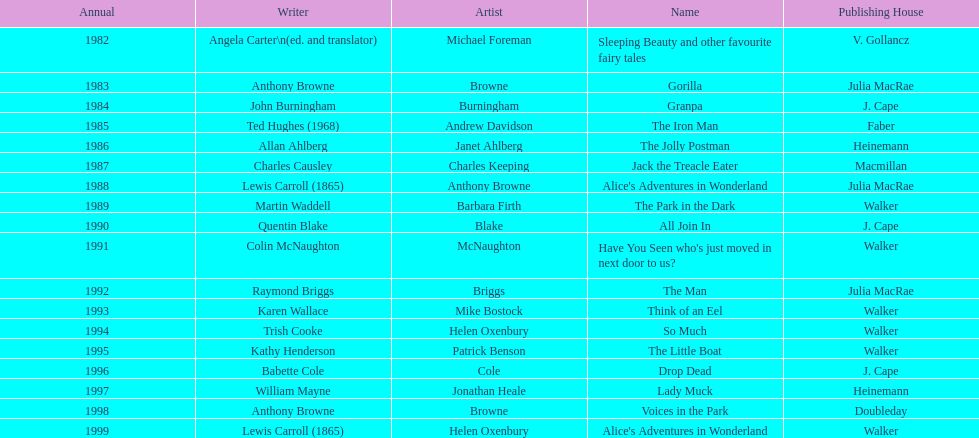How many total titles were published by walker? 5. 